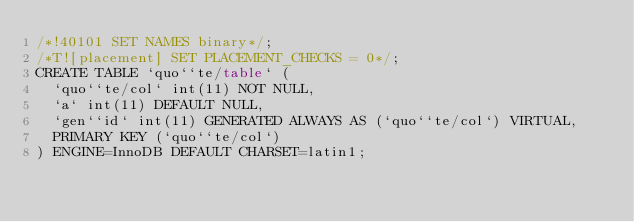Convert code to text. <code><loc_0><loc_0><loc_500><loc_500><_SQL_>/*!40101 SET NAMES binary*/;
/*T![placement] SET PLACEMENT_CHECKS = 0*/;
CREATE TABLE `quo``te/table` (
  `quo``te/col` int(11) NOT NULL,
  `a` int(11) DEFAULT NULL,
  `gen``id` int(11) GENERATED ALWAYS AS (`quo``te/col`) VIRTUAL,
  PRIMARY KEY (`quo``te/col`)
) ENGINE=InnoDB DEFAULT CHARSET=latin1;
</code> 